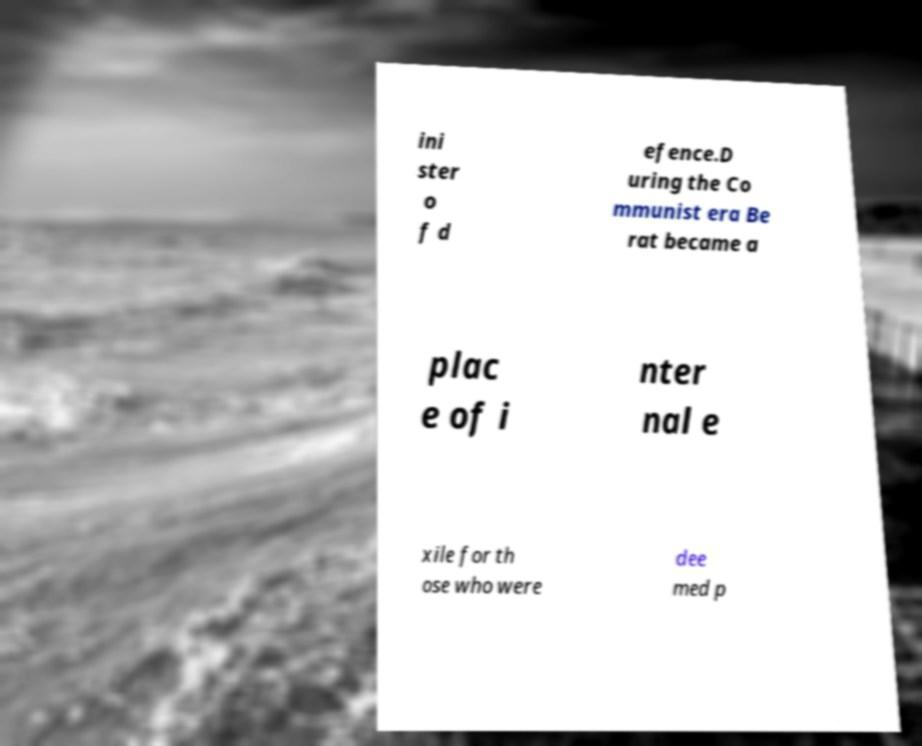I need the written content from this picture converted into text. Can you do that? ini ster o f d efence.D uring the Co mmunist era Be rat became a plac e of i nter nal e xile for th ose who were dee med p 